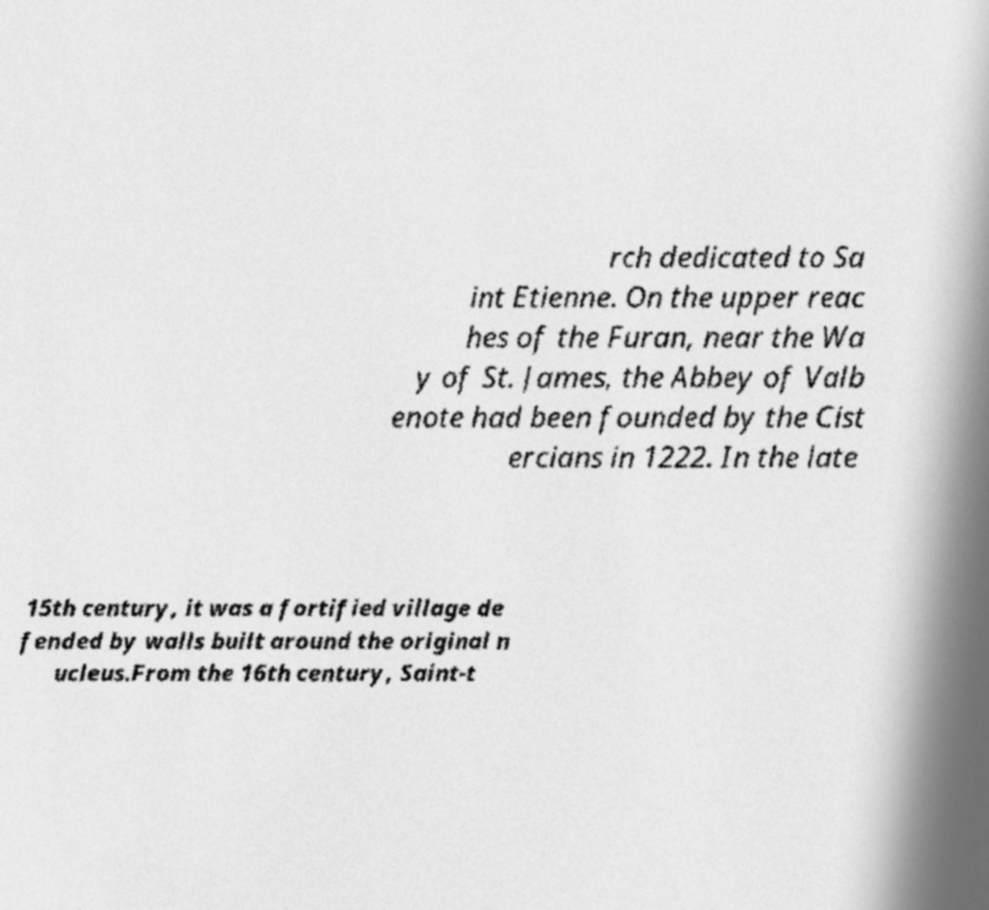Please identify and transcribe the text found in this image. rch dedicated to Sa int Etienne. On the upper reac hes of the Furan, near the Wa y of St. James, the Abbey of Valb enote had been founded by the Cist ercians in 1222. In the late 15th century, it was a fortified village de fended by walls built around the original n ucleus.From the 16th century, Saint-t 